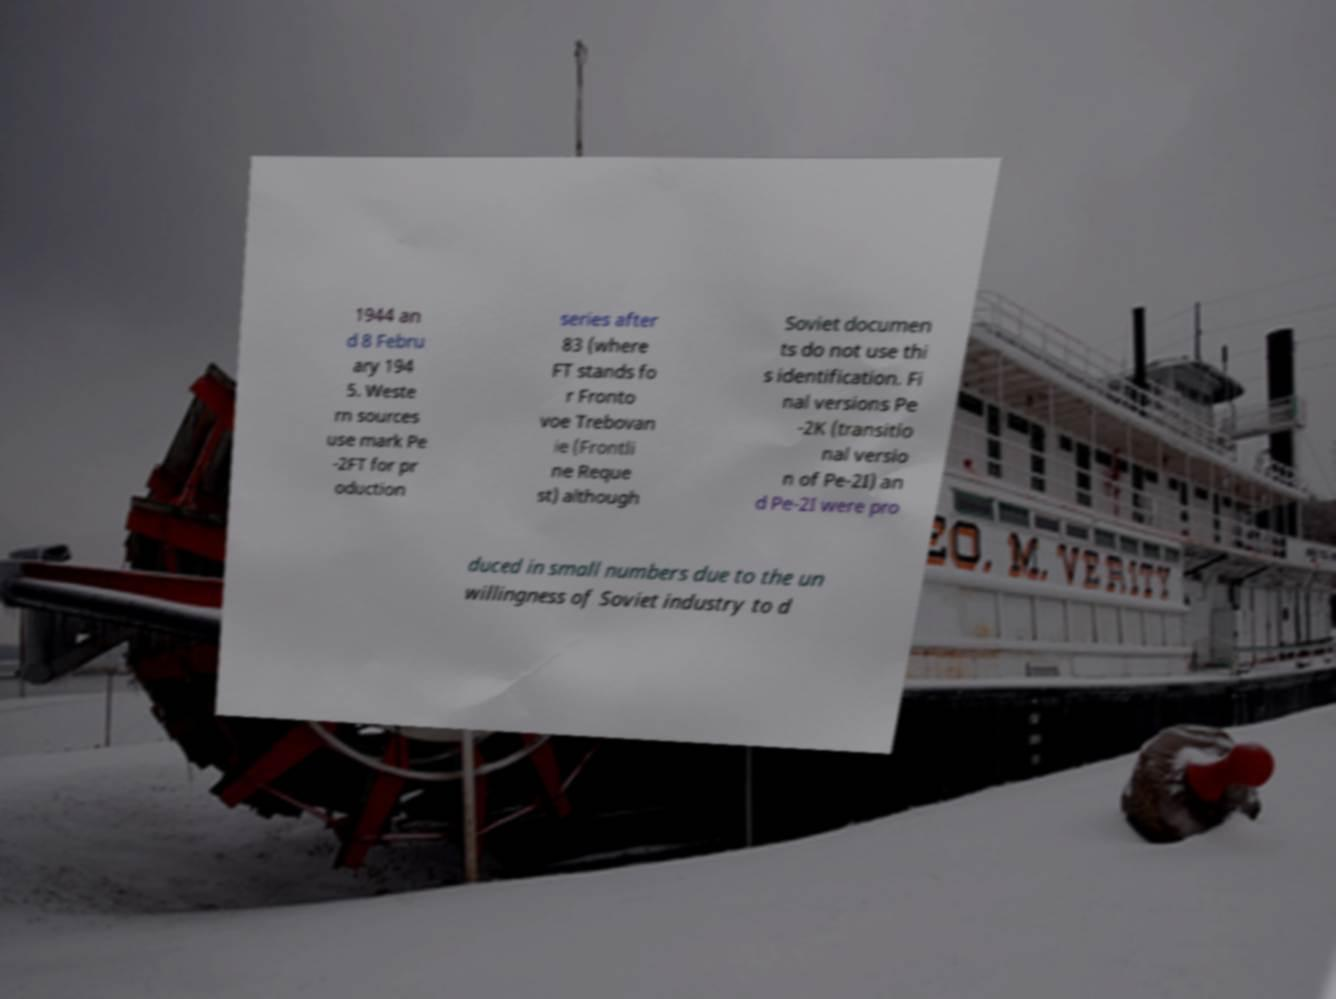For documentation purposes, I need the text within this image transcribed. Could you provide that? 1944 an d 8 Febru ary 194 5. Weste rn sources use mark Pe -2FT for pr oduction series after 83 (where FT stands fo r Fronto voe Trebovan ie (Frontli ne Reque st) although Soviet documen ts do not use thi s identification. Fi nal versions Pe -2K (transitio nal versio n of Pe-2I) an d Pe-2I were pro duced in small numbers due to the un willingness of Soviet industry to d 